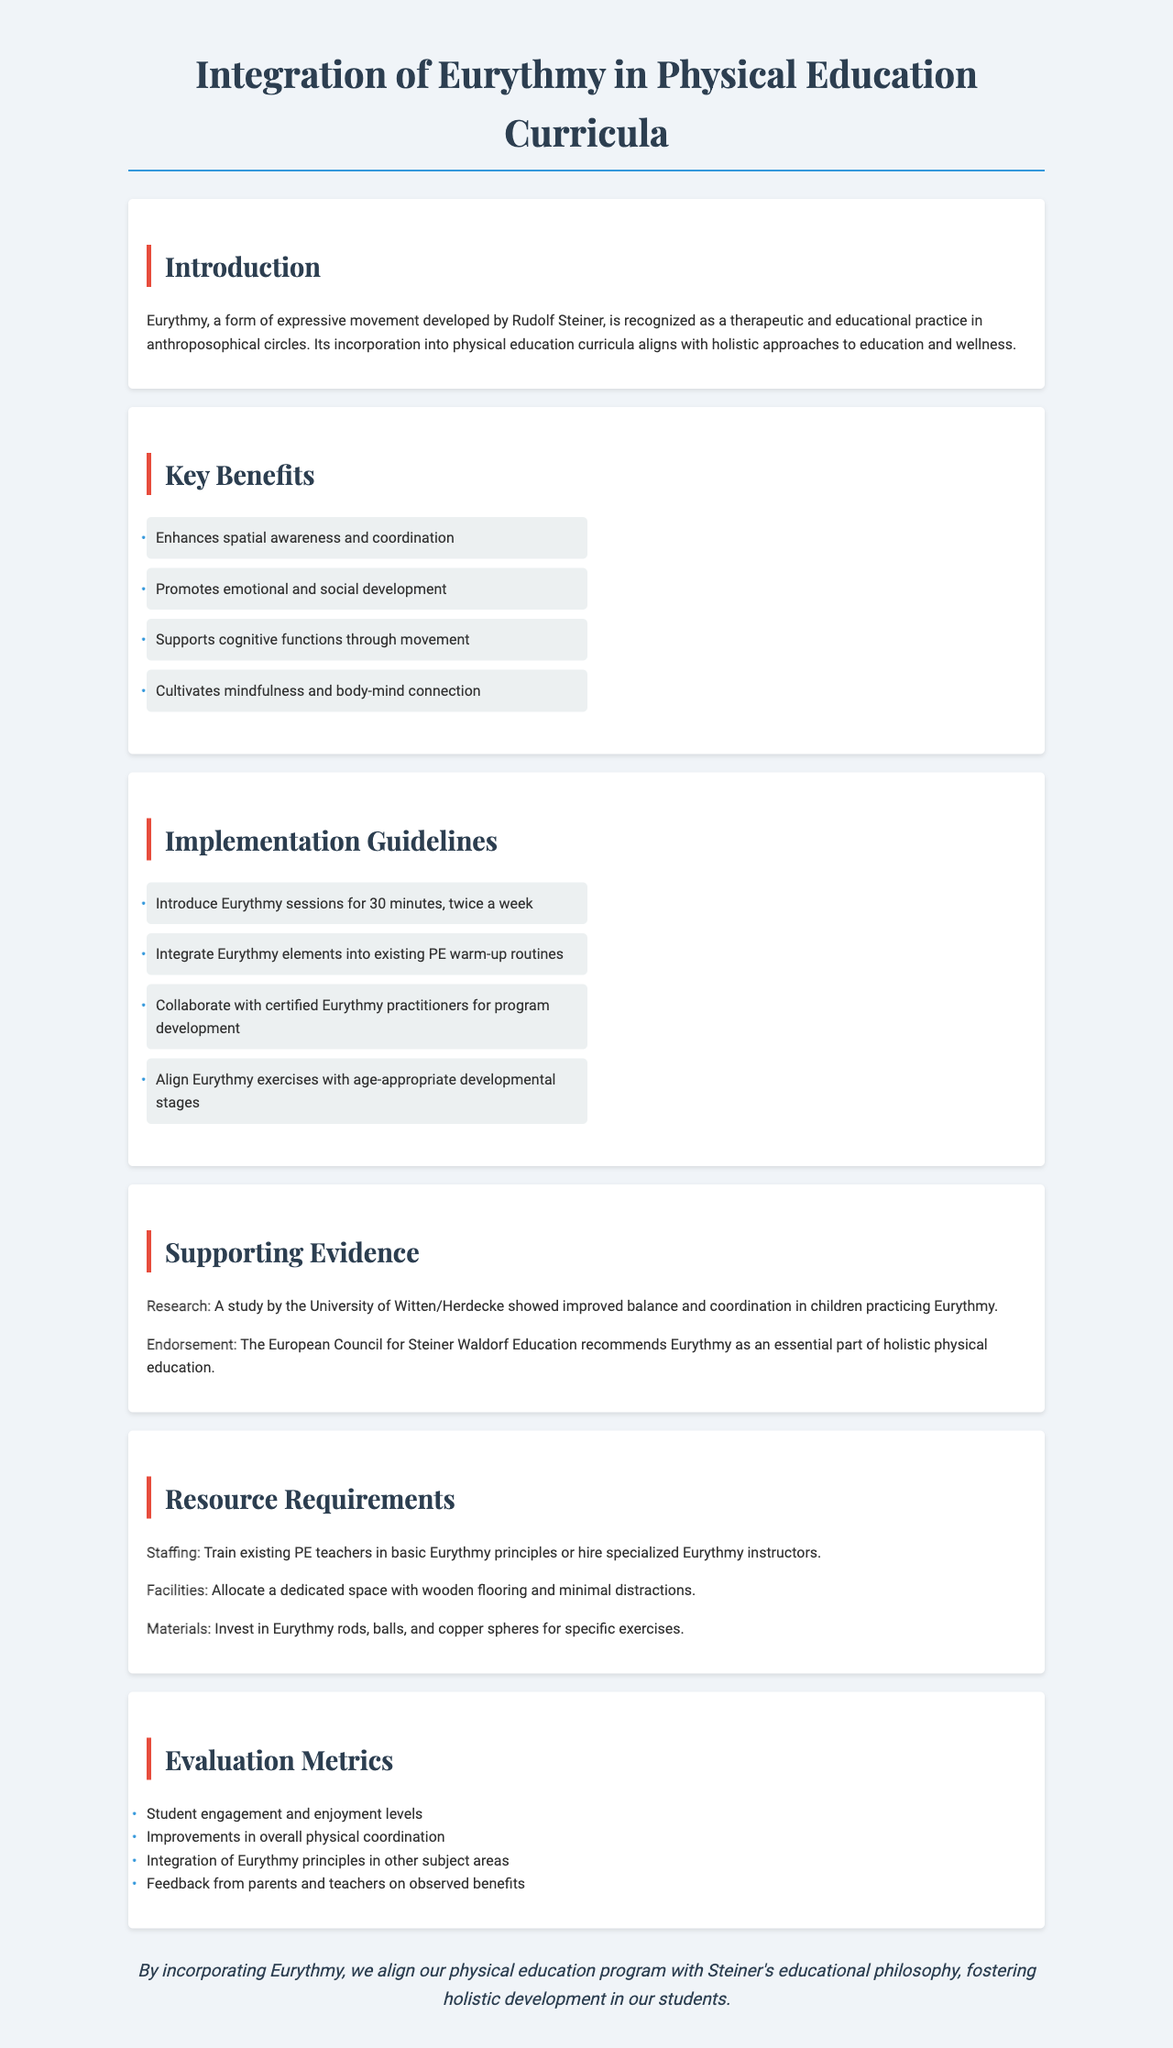What is Eurythmy recognized as? Eurythmy is recognized as a therapeutic and educational practice in anthroposophical circles.
Answer: therapeutic and educational practice How often should Eurythmy sessions be held? The document states Eurythmy sessions should be introduced for 30 minutes, twice a week.
Answer: twice a week What is one key benefit of Eurythmy? The document lists several benefits; one is enhancing spatial awareness and coordination.
Answer: enhances spatial awareness and coordination Who recommends Eurythmy as part of holistic physical education? The European Council for Steiner Waldorf Education recommends Eurythmy.
Answer: European Council for Steiner Waldorf Education What is a required facility for Eurythmy classes? The document indicates the need for a dedicated space with wooden flooring and minimal distractions.
Answer: wooden flooring What should feedback from parents and teachers evaluate? Feedback should evaluate observed benefits from integrating Eurythmy principles.
Answer: observed benefits What is one resource requirement mentioned? A mentioned resource requirement is to train existing PE teachers in basic Eurythmy principles.
Answer: train existing PE teachers What principle is Eurythmy aligned with in physical education? Eurythmy aligns with Steiner's educational philosophy.
Answer: Steiner's educational philosophy What are students expected to improve through Eurythmy according to the evaluation metrics? Students are expected to improve in overall physical coordination.
Answer: overall physical coordination 